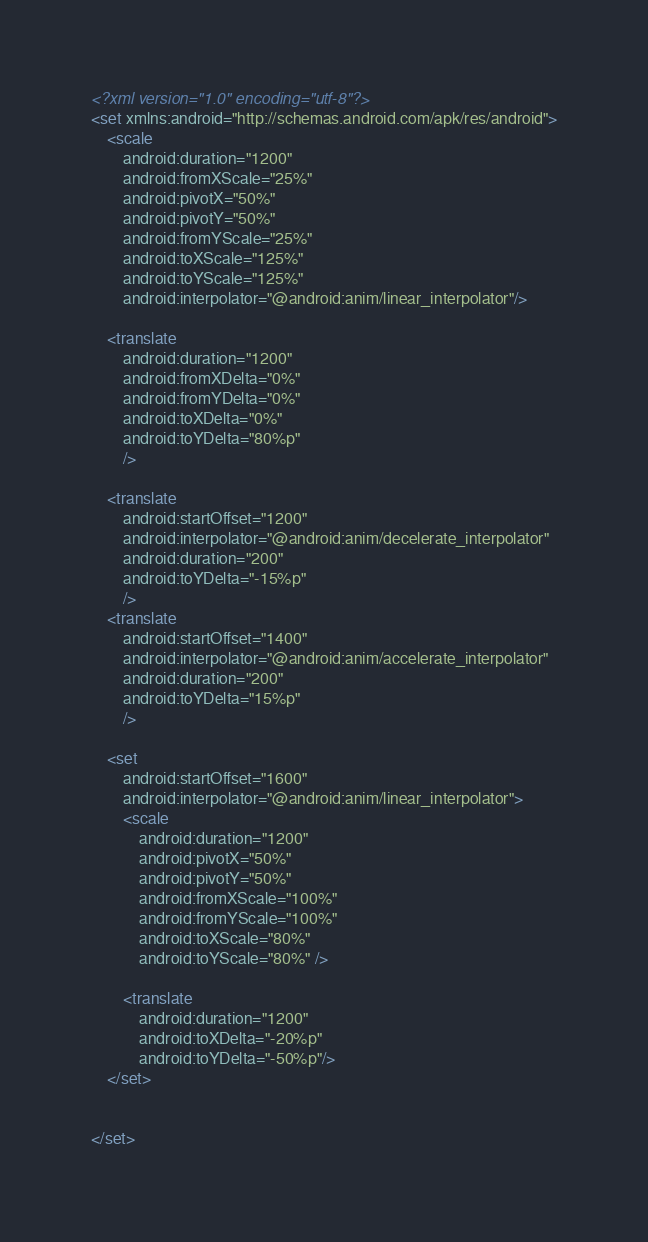<code> <loc_0><loc_0><loc_500><loc_500><_XML_><?xml version="1.0" encoding="utf-8"?>
<set xmlns:android="http://schemas.android.com/apk/res/android">
    <scale
        android:duration="1200"
        android:fromXScale="25%"
        android:pivotX="50%"
        android:pivotY="50%"
        android:fromYScale="25%"
        android:toXScale="125%"
        android:toYScale="125%"
        android:interpolator="@android:anim/linear_interpolator"/>

    <translate
        android:duration="1200"
        android:fromXDelta="0%"
        android:fromYDelta="0%"
        android:toXDelta="0%"
        android:toYDelta="80%p"
        />

    <translate
        android:startOffset="1200"
        android:interpolator="@android:anim/decelerate_interpolator"
        android:duration="200"
        android:toYDelta="-15%p"
        />
    <translate
        android:startOffset="1400"
        android:interpolator="@android:anim/accelerate_interpolator"
        android:duration="200"
        android:toYDelta="15%p"
        />

    <set
        android:startOffset="1600"
        android:interpolator="@android:anim/linear_interpolator">
        <scale
            android:duration="1200"
            android:pivotX="50%"
            android:pivotY="50%"
            android:fromXScale="100%"
            android:fromYScale="100%"
            android:toXScale="80%"
            android:toYScale="80%" />

        <translate
            android:duration="1200"
            android:toXDelta="-20%p"
            android:toYDelta="-50%p"/>
    </set>


</set></code> 